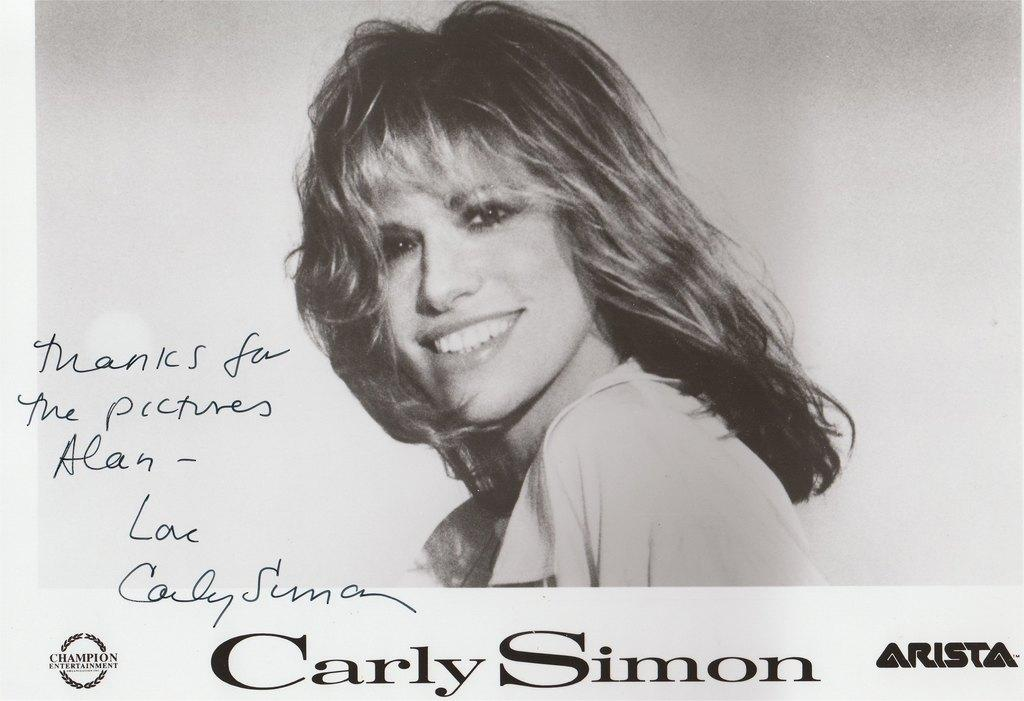What is the main subject of the poster in the image? The poster features a woman smiling. What is the woman in the poster doing? The woman is smiling in the poster. Is there any text on the poster? Yes, there is text at the bottom of the poster. How many rays are visible around the woman in the poster? There are no rays visible around the woman in the poster. What type of sticks are being used by the woman in the poster? There are no sticks present in the poster; the woman is simply smiling. 